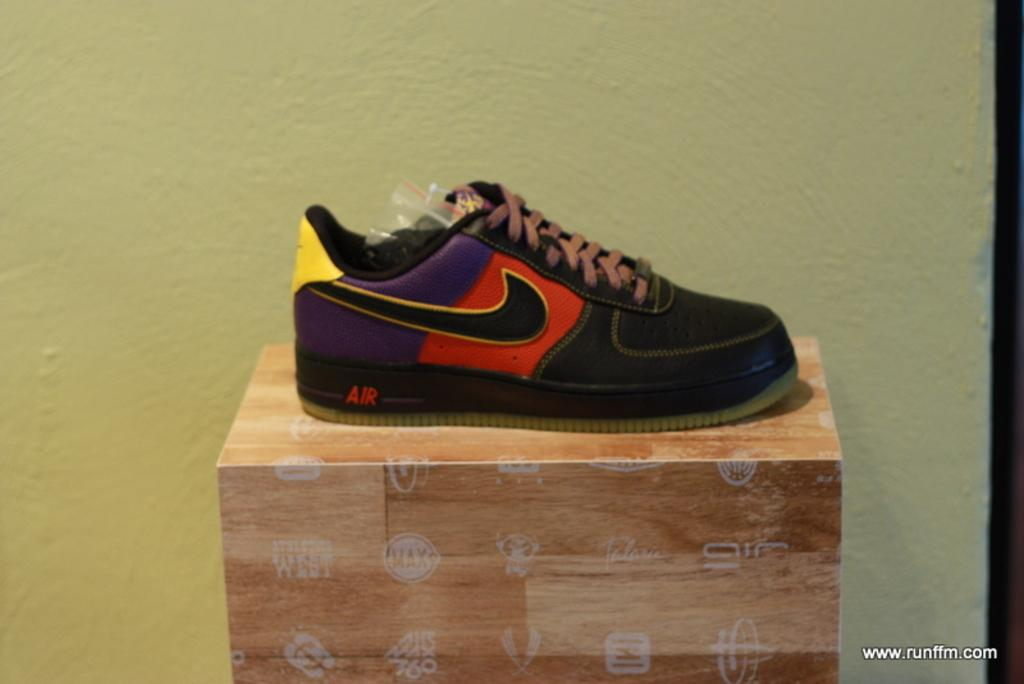What object is placed on a box in the image? There is a shoe on a box in the image. Where is the box located in relation to other objects in the image? The box is in front of a wall in the image. What type of pot is visible on the stove in the image? There is no pot or stove present in the image; it only features a shoe on a box in front of a wall. 